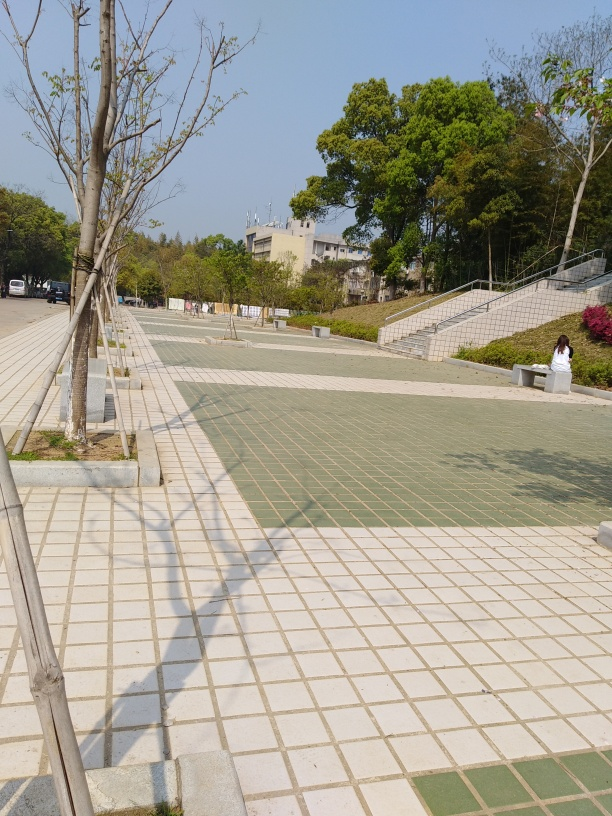What can be inferred about the usage of this public space based on the layout and structures? Based on the wide pathways and the arrangement of stairs, it seems to be designed to accommodate a significant number of pedestrians. The presence of benches implies it's a place where people can rest, suggesting it's frequented by walkers or patrons who might use this space for leisure, possibly during breaks or for outdoor events. Are there any architectural styles or design principles evident in the image? While there is no single predominant architectural style visible, the design appears modern and functional, with an emphasis on accessibility and open space. The use of geometric shapes and the orderly arrangement of the stairs and pathways reflect design principles that prioritize functionality and simplicity. 